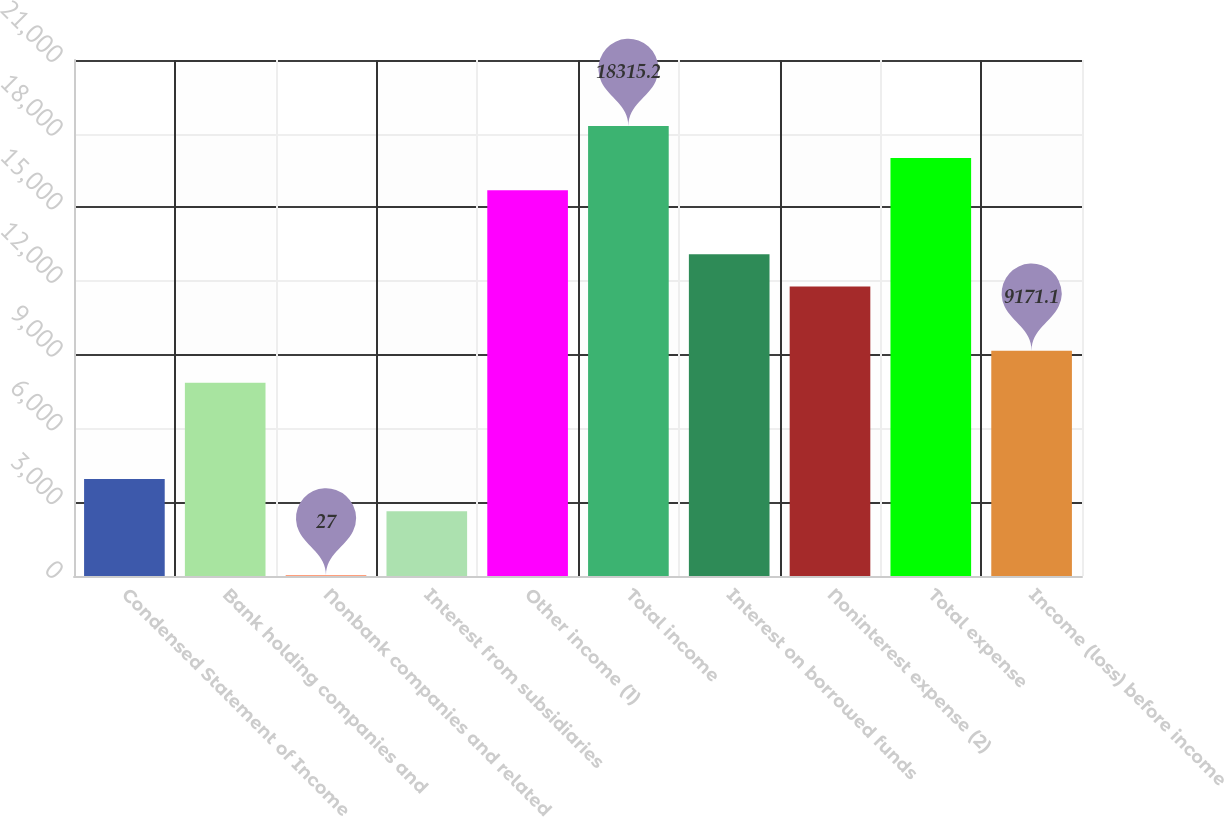<chart> <loc_0><loc_0><loc_500><loc_500><bar_chart><fcel>Condensed Statement of Income<fcel>Bank holding companies and<fcel>Nonbank companies and related<fcel>Interest from subsidiaries<fcel>Other income (1)<fcel>Total income<fcel>Interest on borrowed funds<fcel>Noninterest expense (2)<fcel>Total expense<fcel>Income (loss) before income<nl><fcel>3945.9<fcel>7864.8<fcel>27<fcel>2639.6<fcel>15702.6<fcel>18315.2<fcel>13090<fcel>11783.7<fcel>17008.9<fcel>9171.1<nl></chart> 